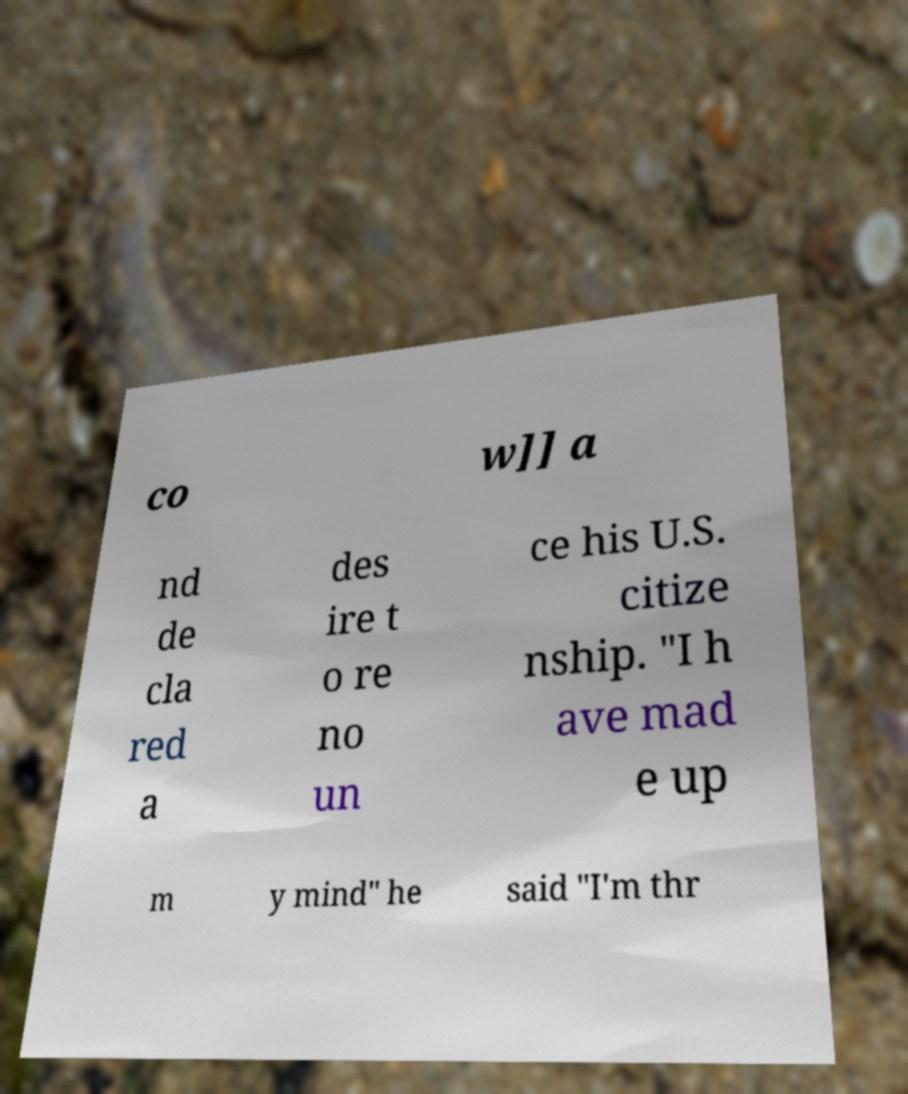I need the written content from this picture converted into text. Can you do that? co w]] a nd de cla red a des ire t o re no un ce his U.S. citize nship. "I h ave mad e up m y mind" he said "I'm thr 